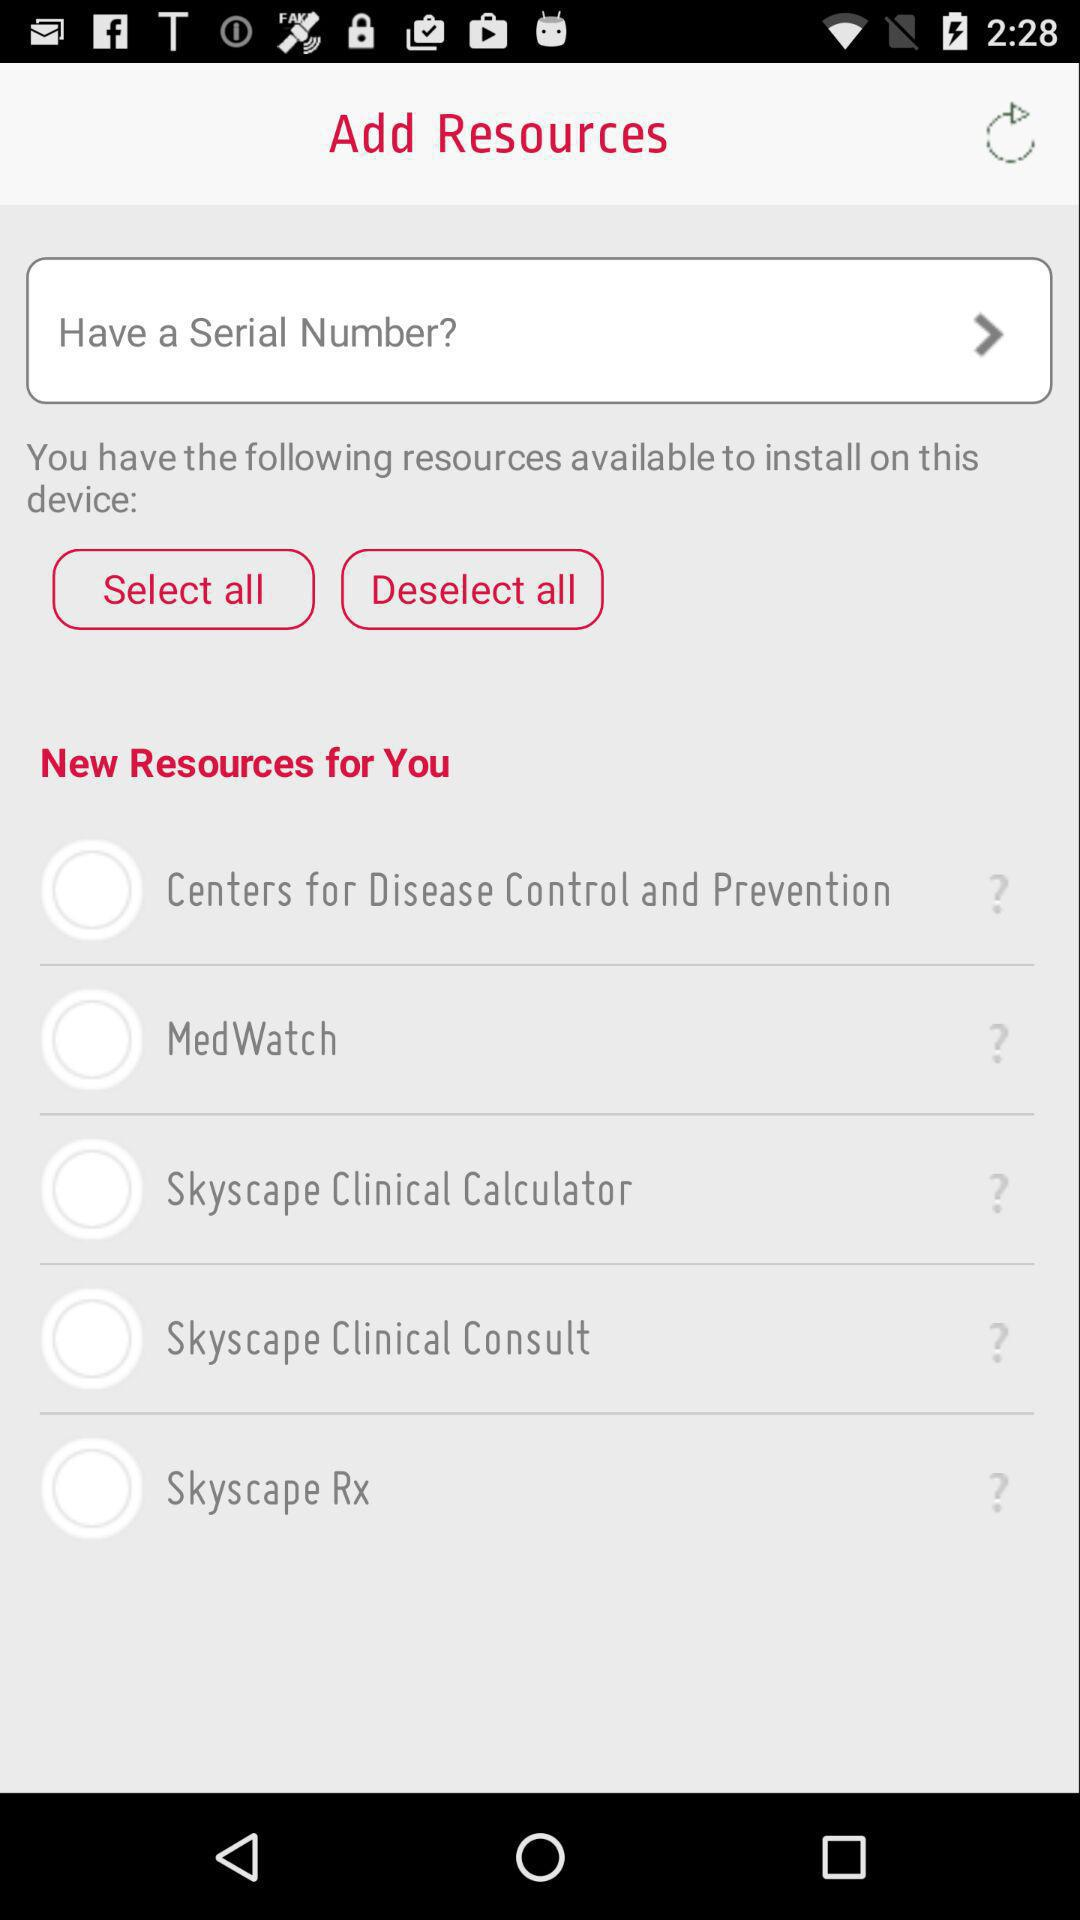How many resources are available to install?
Answer the question using a single word or phrase. 5 